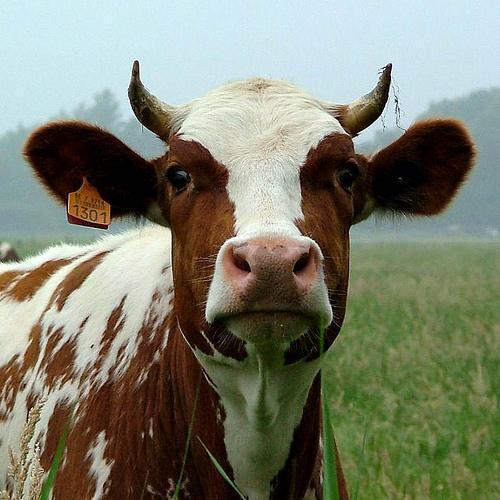How many steer are there?
Give a very brief answer. 1. 